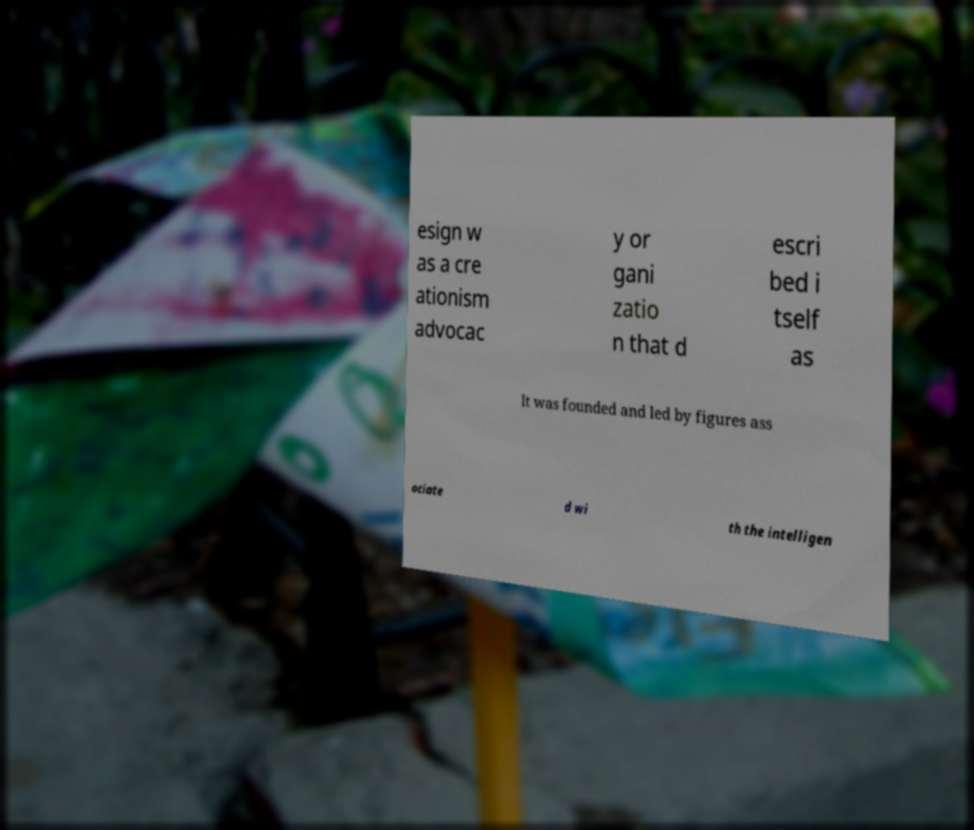I need the written content from this picture converted into text. Can you do that? esign w as a cre ationism advocac y or gani zatio n that d escri bed i tself as It was founded and led by figures ass ociate d wi th the intelligen 